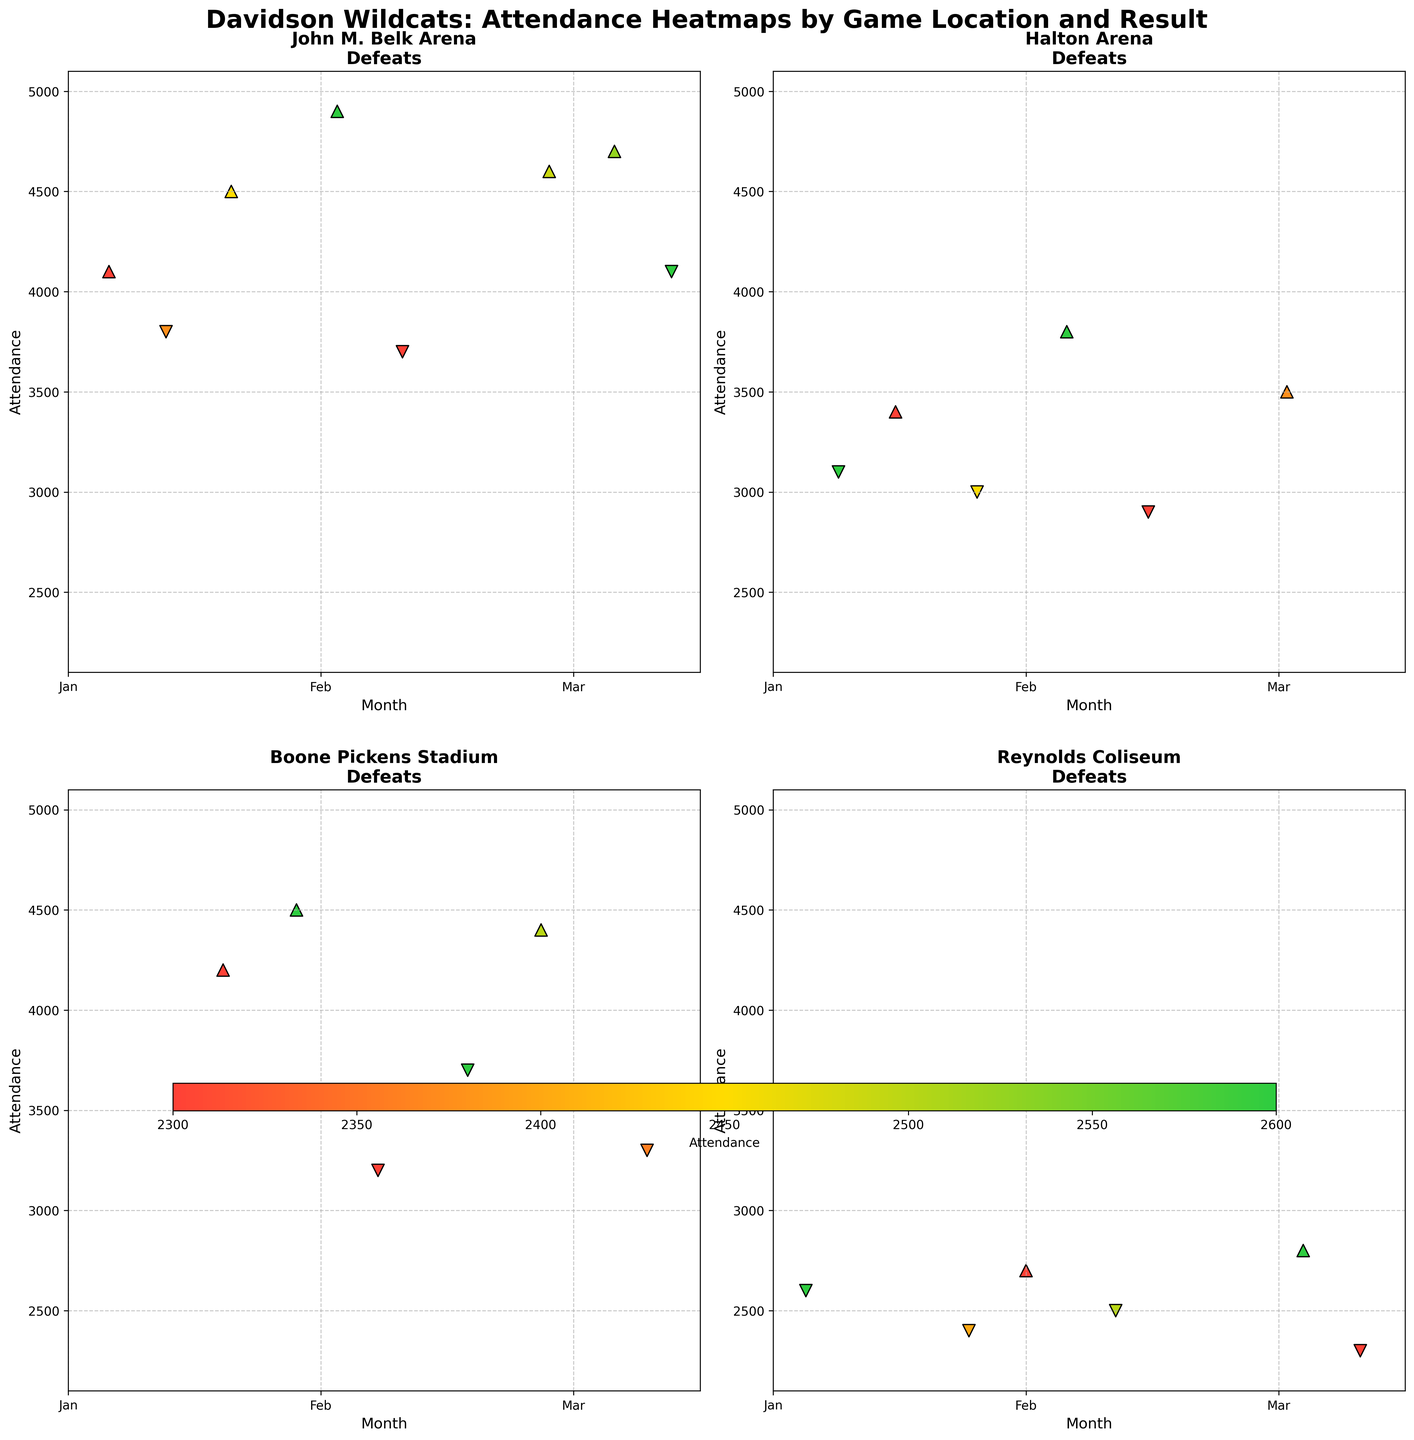What's the title of the figure? The title of the figure is displayed prominently at the top of the plot. It reads "Davidson Wildcats: Attendance Heatmaps by Game Location and Result."
Answer: Davidson Wildcats: Attendance Heatmaps by Game Location and Result How are wins and losses represented in the scatterplot markers? The markers for wins and losses are different shapes and colors. Wins are shown as green upwards-pointing triangles, while losses are shown as red downwards-pointing triangles.
Answer: Wins: green ^, Losses: red v In which location do victories have the highest attendance? To find the location with the highest attendance for victories, compare the peak attendance values for wins in each subplot. John M. Belk Arena has the highest peak attendance for wins at approximately 4900.
Answer: John M. Belk Arena Which months show the attendance data on the x-axis? The x-axis shows time progression in months, labeled as 'Jan', 'Feb', and 'Mar'.
Answer: January, February, March Which location has the least variation in attendance for losses? Look at the range of attendance values for losses in each subplot. Reynolds Coliseum has the least variation, with attendance ranging between 2300 and 2600.
Answer: Reynolds Coliseum What is the average attendance for wins at Halton Arena? Identify the attendance values for wins at Halton Arena (3400, 3800, 3500). Sum these values and divide by the number of games to find the average: (3400 + 3800 + 3500) / 3 = 3566.67.
Answer: 3566.67 In which location does the trend show a decrease in attendance for losses over time? Observe the attendance trends for losses in each location. In Boone Pickens Stadium, the attendance for losses decreases over time: 3200, 3700, 3300.
Answer: Boone Pickens Stadium What's the attendance difference between the highest and lowest attended game at John M. Belk Arena? Find the maximum and minimum attendance values for games at John M. Belk Arena and subtract the lowest value from the highest. The highest is 4900, and the lowest is 3700. The difference is 4900 - 3700 = 1200.
Answer: 1200 